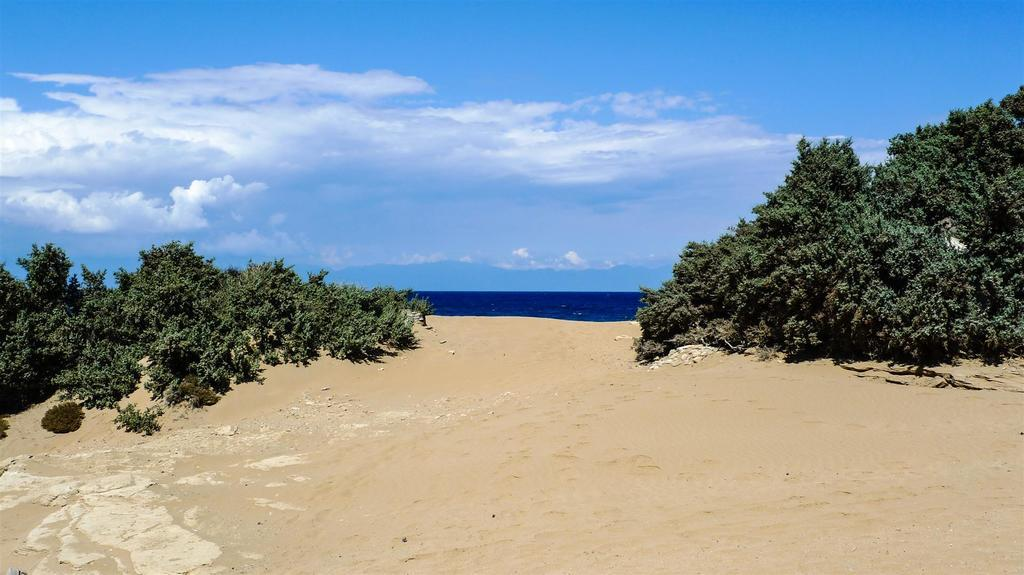What type of vegetation can be seen in the image? There are trees in the image. What is visible at the top of the image? The sky is visible at the top of the image. What can be seen in the sky? There are clouds in the sky. What type of terrain is present at the bottom of the image? Sand is present at the bottom of the image. What is the water in the image? Water is visible in the image. Where is the rock located in the image? There is a rock on the left side of the image. How many eggs are present in the image? There are no eggs present in the image. What type of bed can be seen in the image? There are no beds present in the image. 